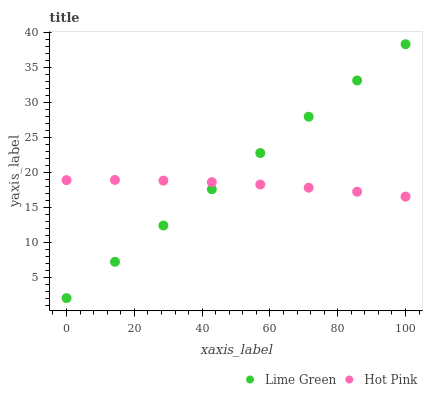Does Hot Pink have the minimum area under the curve?
Answer yes or no. Yes. Does Lime Green have the maximum area under the curve?
Answer yes or no. Yes. Does Lime Green have the minimum area under the curve?
Answer yes or no. No. Is Lime Green the smoothest?
Answer yes or no. Yes. Is Hot Pink the roughest?
Answer yes or no. Yes. Is Lime Green the roughest?
Answer yes or no. No. Does Lime Green have the lowest value?
Answer yes or no. Yes. Does Lime Green have the highest value?
Answer yes or no. Yes. Does Lime Green intersect Hot Pink?
Answer yes or no. Yes. Is Lime Green less than Hot Pink?
Answer yes or no. No. Is Lime Green greater than Hot Pink?
Answer yes or no. No. 